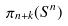<formula> <loc_0><loc_0><loc_500><loc_500>\pi _ { n + k } ( S ^ { n } )</formula> 